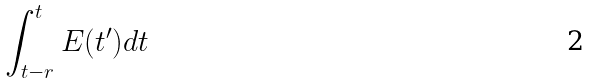Convert formula to latex. <formula><loc_0><loc_0><loc_500><loc_500>\int _ { t - r } ^ { t } E ( t ^ { \prime } ) d t</formula> 